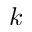Convert formula to latex. <formula><loc_0><loc_0><loc_500><loc_500>k</formula> 